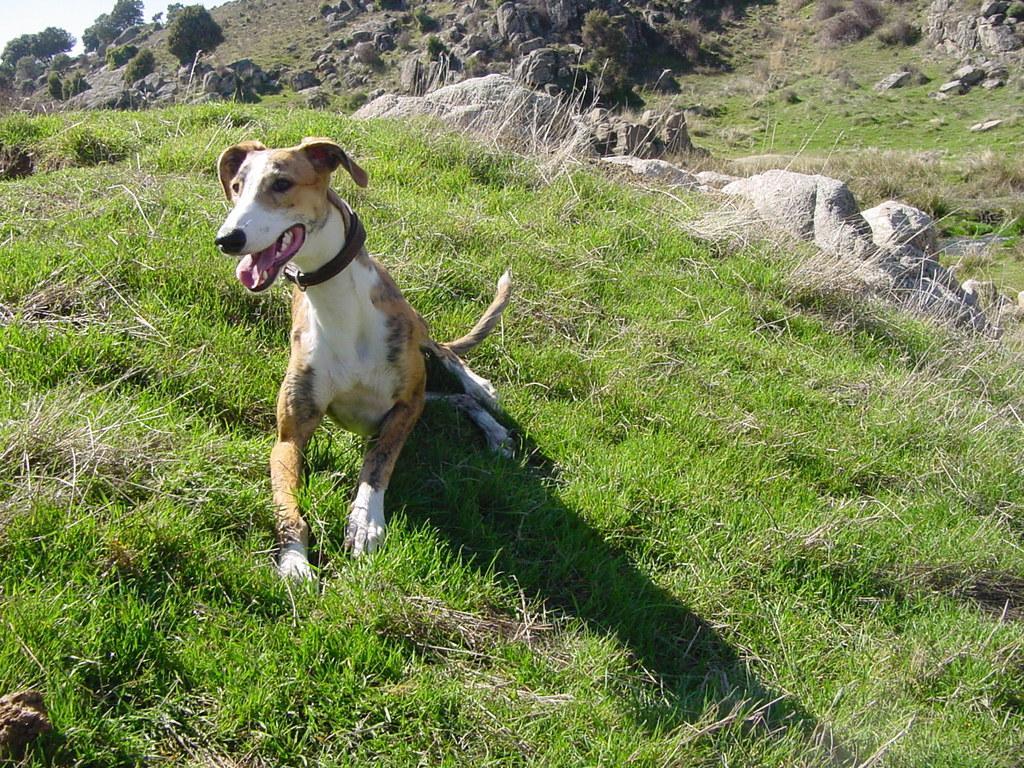In one or two sentences, can you explain what this image depicts? In this picture we see a dog. It is white and brown in color with a belt to its neck and we see rocks and trees and grass on the ground. 